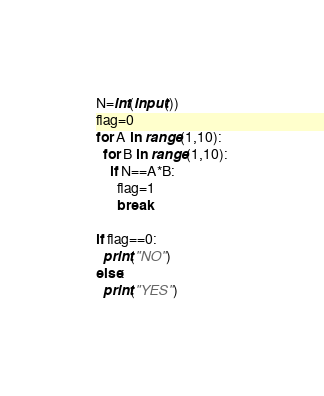Convert code to text. <code><loc_0><loc_0><loc_500><loc_500><_Python_>N=int(input())
flag=0
for A in range(1,10):
  for B in range(1,10):
    if N==A*B:
      flag=1
      break
      
if flag==0:
  print("NO")
else:
  print("YES")</code> 